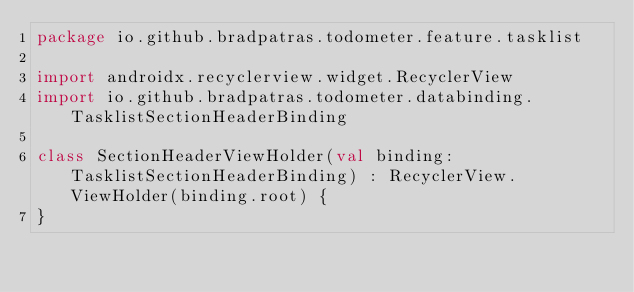Convert code to text. <code><loc_0><loc_0><loc_500><loc_500><_Kotlin_>package io.github.bradpatras.todometer.feature.tasklist

import androidx.recyclerview.widget.RecyclerView
import io.github.bradpatras.todometer.databinding.TasklistSectionHeaderBinding

class SectionHeaderViewHolder(val binding: TasklistSectionHeaderBinding) : RecyclerView.ViewHolder(binding.root) {
}</code> 